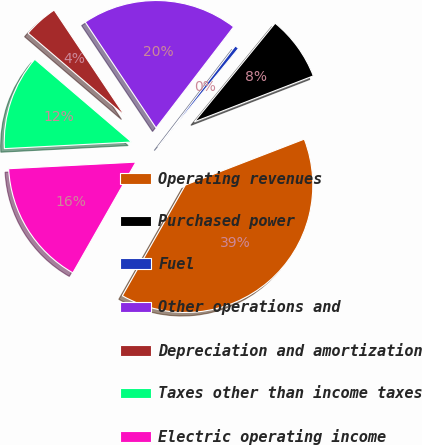Convert chart. <chart><loc_0><loc_0><loc_500><loc_500><pie_chart><fcel>Operating revenues<fcel>Purchased power<fcel>Fuel<fcel>Other operations and<fcel>Depreciation and amortization<fcel>Taxes other than income taxes<fcel>Electric operating income<nl><fcel>39.1%<fcel>8.22%<fcel>0.5%<fcel>19.8%<fcel>4.36%<fcel>12.08%<fcel>15.94%<nl></chart> 